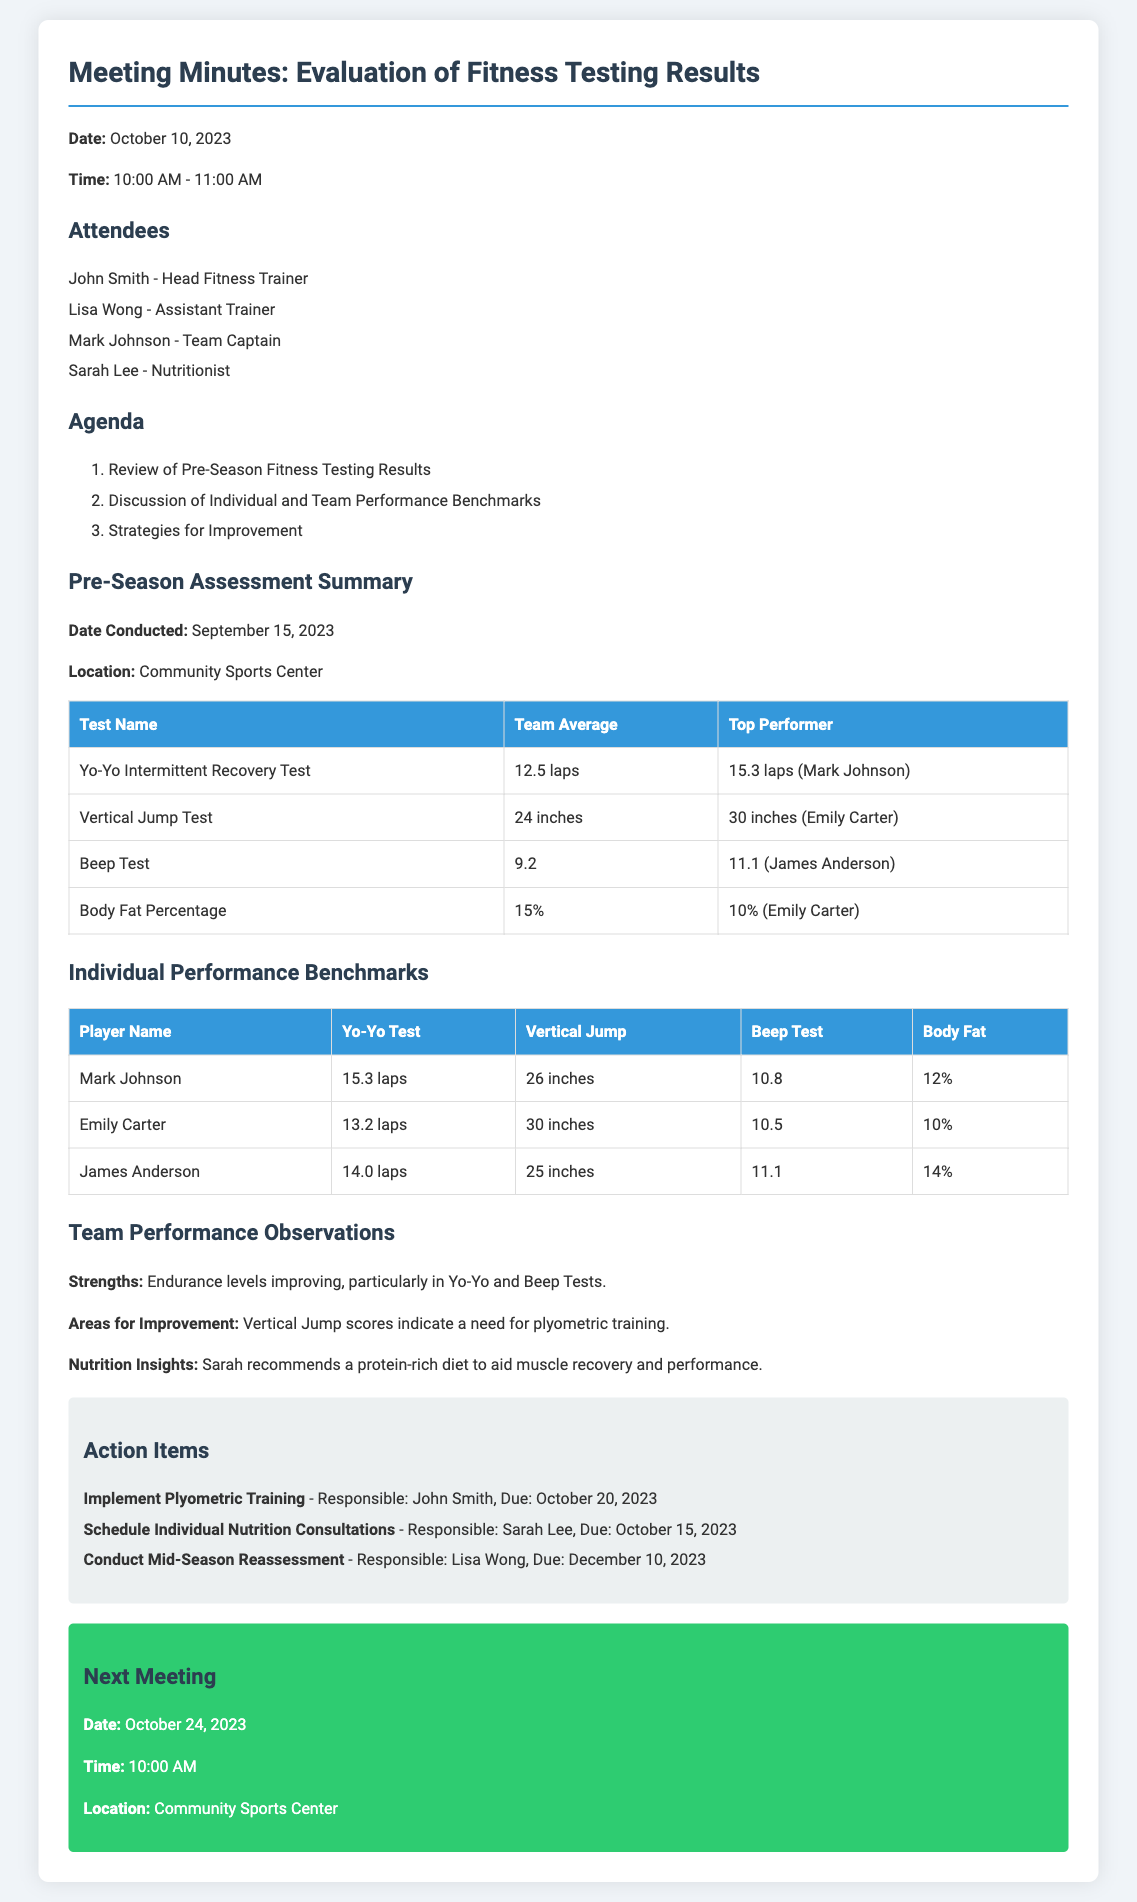What date was the fitness testing conducted? The date of the fitness testing is mentioned in the summary section as September 15, 2023.
Answer: September 15, 2023 Who was the top performer in the Yo-Yo Intermittent Recovery Test? The top performer in the Yo-Yo Intermittent Recovery Test is highlighted in the table as Mark Johnson with 15.3 laps.
Answer: Mark Johnson What is the team average for the Vertical Jump Test? The team average for the Vertical Jump Test is provided in the results table as 24 inches.
Answer: 24 inches What area for improvement was identified in the document? The document notes that the Vertical Jump scores indicate a need for plyometric training, as stated in the observations.
Answer: Plyometric training What action item is scheduled for October 15, 2023? The document lists the action item for individual nutrition consultations scheduled for October 15, 2023, along with the responsible person.
Answer: Schedule Individual Nutrition Consultations How many laps did Emily Carter achieve in the Yo-Yo Test? Emily Carter’s performance in the Yo-Yo Test is specified as 13.2 laps in the individual performance benchmarks table.
Answer: 13.2 laps What is the next meeting date? The next meeting date is clearly stated at the end of the document as October 24, 2023.
Answer: October 24, 2023 Which player has the highest body fat percentage? Looking at the individual performance table, James Anderson's body fat percentage is the highest at 14%.
Answer: 14% How many inches is the top performer’s Vertical Jump? The vertical jump of the top performer, Emily Carter, is mentioned in the table as 30 inches.
Answer: 30 inches 